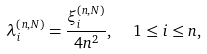Convert formula to latex. <formula><loc_0><loc_0><loc_500><loc_500>\lambda _ { i } ^ { ( n , N ) } = \frac { \xi _ { i } ^ { ( n , N ) } } { 4 n ^ { 2 } } , \ \ 1 \leq i \leq n ,</formula> 